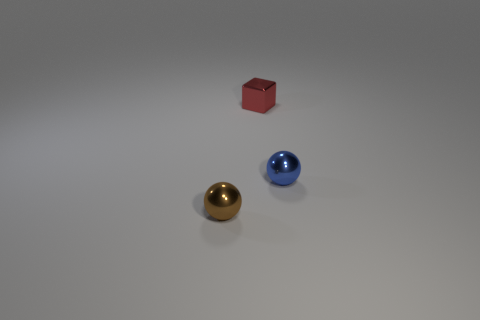Add 1 large green rubber things. How many objects exist? 4 Subtract all balls. How many objects are left? 1 Subtract all balls. Subtract all green objects. How many objects are left? 1 Add 1 small blue things. How many small blue things are left? 2 Add 3 small purple matte objects. How many small purple matte objects exist? 3 Subtract 1 red cubes. How many objects are left? 2 